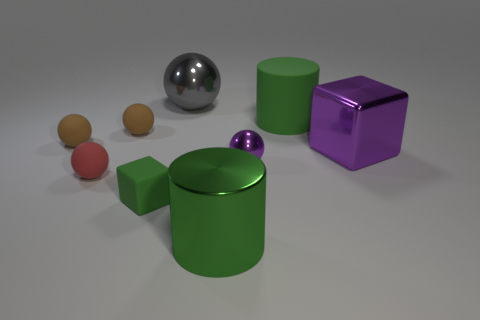Is there anything else that is made of the same material as the green block?
Provide a succinct answer. Yes. How many tiny things are purple rubber cylinders or red spheres?
Your answer should be compact. 1. What number of objects are large green objects in front of the red ball or small shiny things?
Offer a terse response. 2. Is the matte block the same color as the large matte object?
Provide a succinct answer. Yes. What number of other things are there of the same shape as the small purple object?
Keep it short and to the point. 4. What number of blue objects are either big metallic cubes or big metal spheres?
Offer a terse response. 0. What is the color of the large block that is made of the same material as the large gray sphere?
Give a very brief answer. Purple. Does the big cylinder that is to the left of the purple shiny ball have the same material as the large object right of the big green rubber cylinder?
Your response must be concise. Yes. The metal thing that is the same color as the large cube is what size?
Keep it short and to the point. Small. There is a small ball that is in front of the small shiny object; what material is it?
Provide a succinct answer. Rubber. 